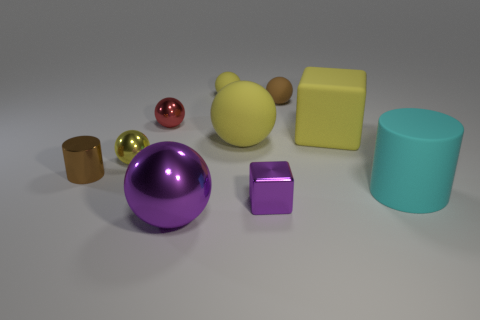How many yellow balls must be subtracted to get 1 yellow balls? 2 Subtract all big yellow matte balls. How many balls are left? 5 Subtract all red spheres. How many spheres are left? 5 Subtract all brown cylinders. How many yellow balls are left? 3 Subtract 2 cubes. How many cubes are left? 0 Subtract 0 gray balls. How many objects are left? 10 Subtract all spheres. How many objects are left? 4 Subtract all gray cubes. Subtract all brown balls. How many cubes are left? 2 Subtract all small balls. Subtract all tiny purple shiny cubes. How many objects are left? 5 Add 4 tiny cylinders. How many tiny cylinders are left? 5 